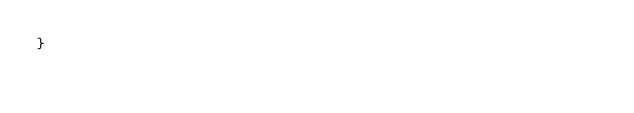Convert code to text. <code><loc_0><loc_0><loc_500><loc_500><_PHP_>}
</code> 